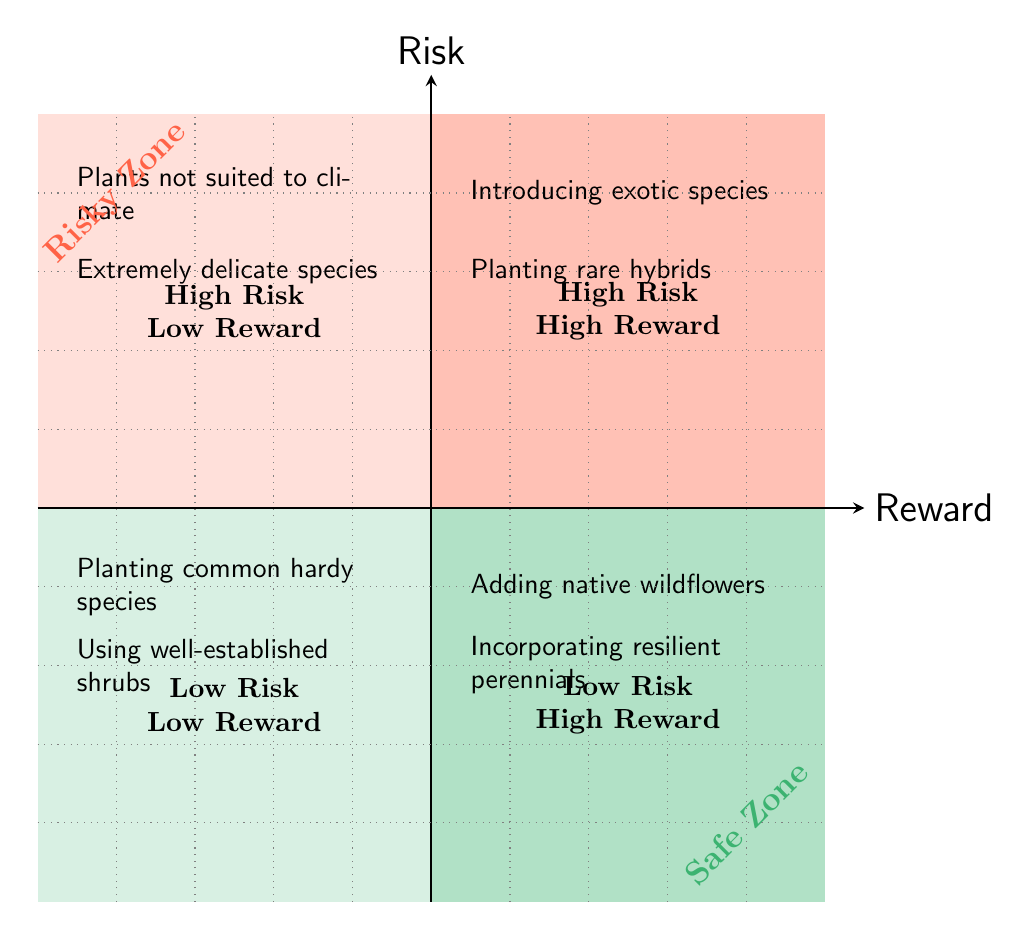What are the two examples in the High Risk High Reward quadrant? The quadrant is labeled High Risk High Reward, and two specific examples listed in this section are "Introducing exotic species like Monstera Deliciosa" and "Planting rare hybrid plants such as Pink Princess Philodendron."
Answer: Introducing exotic species like Monstera Deliciosa, Planting rare hybrid plants such as Pink Princess Philodendron How many examples are listed in the Low Risk Low Reward quadrant? Observing the Low Risk Low Reward quadrant, we can see there are two examples provided: "Planting common and hardy species like Marigolds" and "Using well-established shrubs like Boxwood." The count of examples is two.
Answer: 2 In which quadrant would you find the example of planting Black-eyed Susan? The example of "Adding native wildflowers like Black-eyed Susan" is located in the Low Risk High Reward quadrant based on its classification of being both beneficial and safer to plant.
Answer: Low Risk High Reward What type of plants might result in Low Reward despite being High Risk according to the diagram? The examples that illustrate High Risk Low Reward include "Using plants not suited to the local climate, e.g., Hibiscus in temperate zones" and "Experimenting with extremely delicate species like Maidenhair Ferns," indicating that even though these involve risks, they do not yield significant benefits.
Answer: Using plants not suited to the local climate, e.g., Hibiscus in temperate zones; Experimenting with extremely delicate species like Maidenhair Ferns What is a characteristic of the Low Risk High Reward quadrant plants? Plants categorized in the Low Risk High Reward quadrant are native and resilient types, like "Adding native wildflowers like Black-eyed Susan" and "Incorporating resilient perennials such as Hostas." These plants generally thrive well and also provide good rewards.
Answer: Native and resilient types What color represents the High Risk High Reward quadrant in the diagram? The High Risk High Reward quadrant is colored with a darker shade of risky red, indicating the high risk associated with the plants listed within it.
Answer: Risky red 